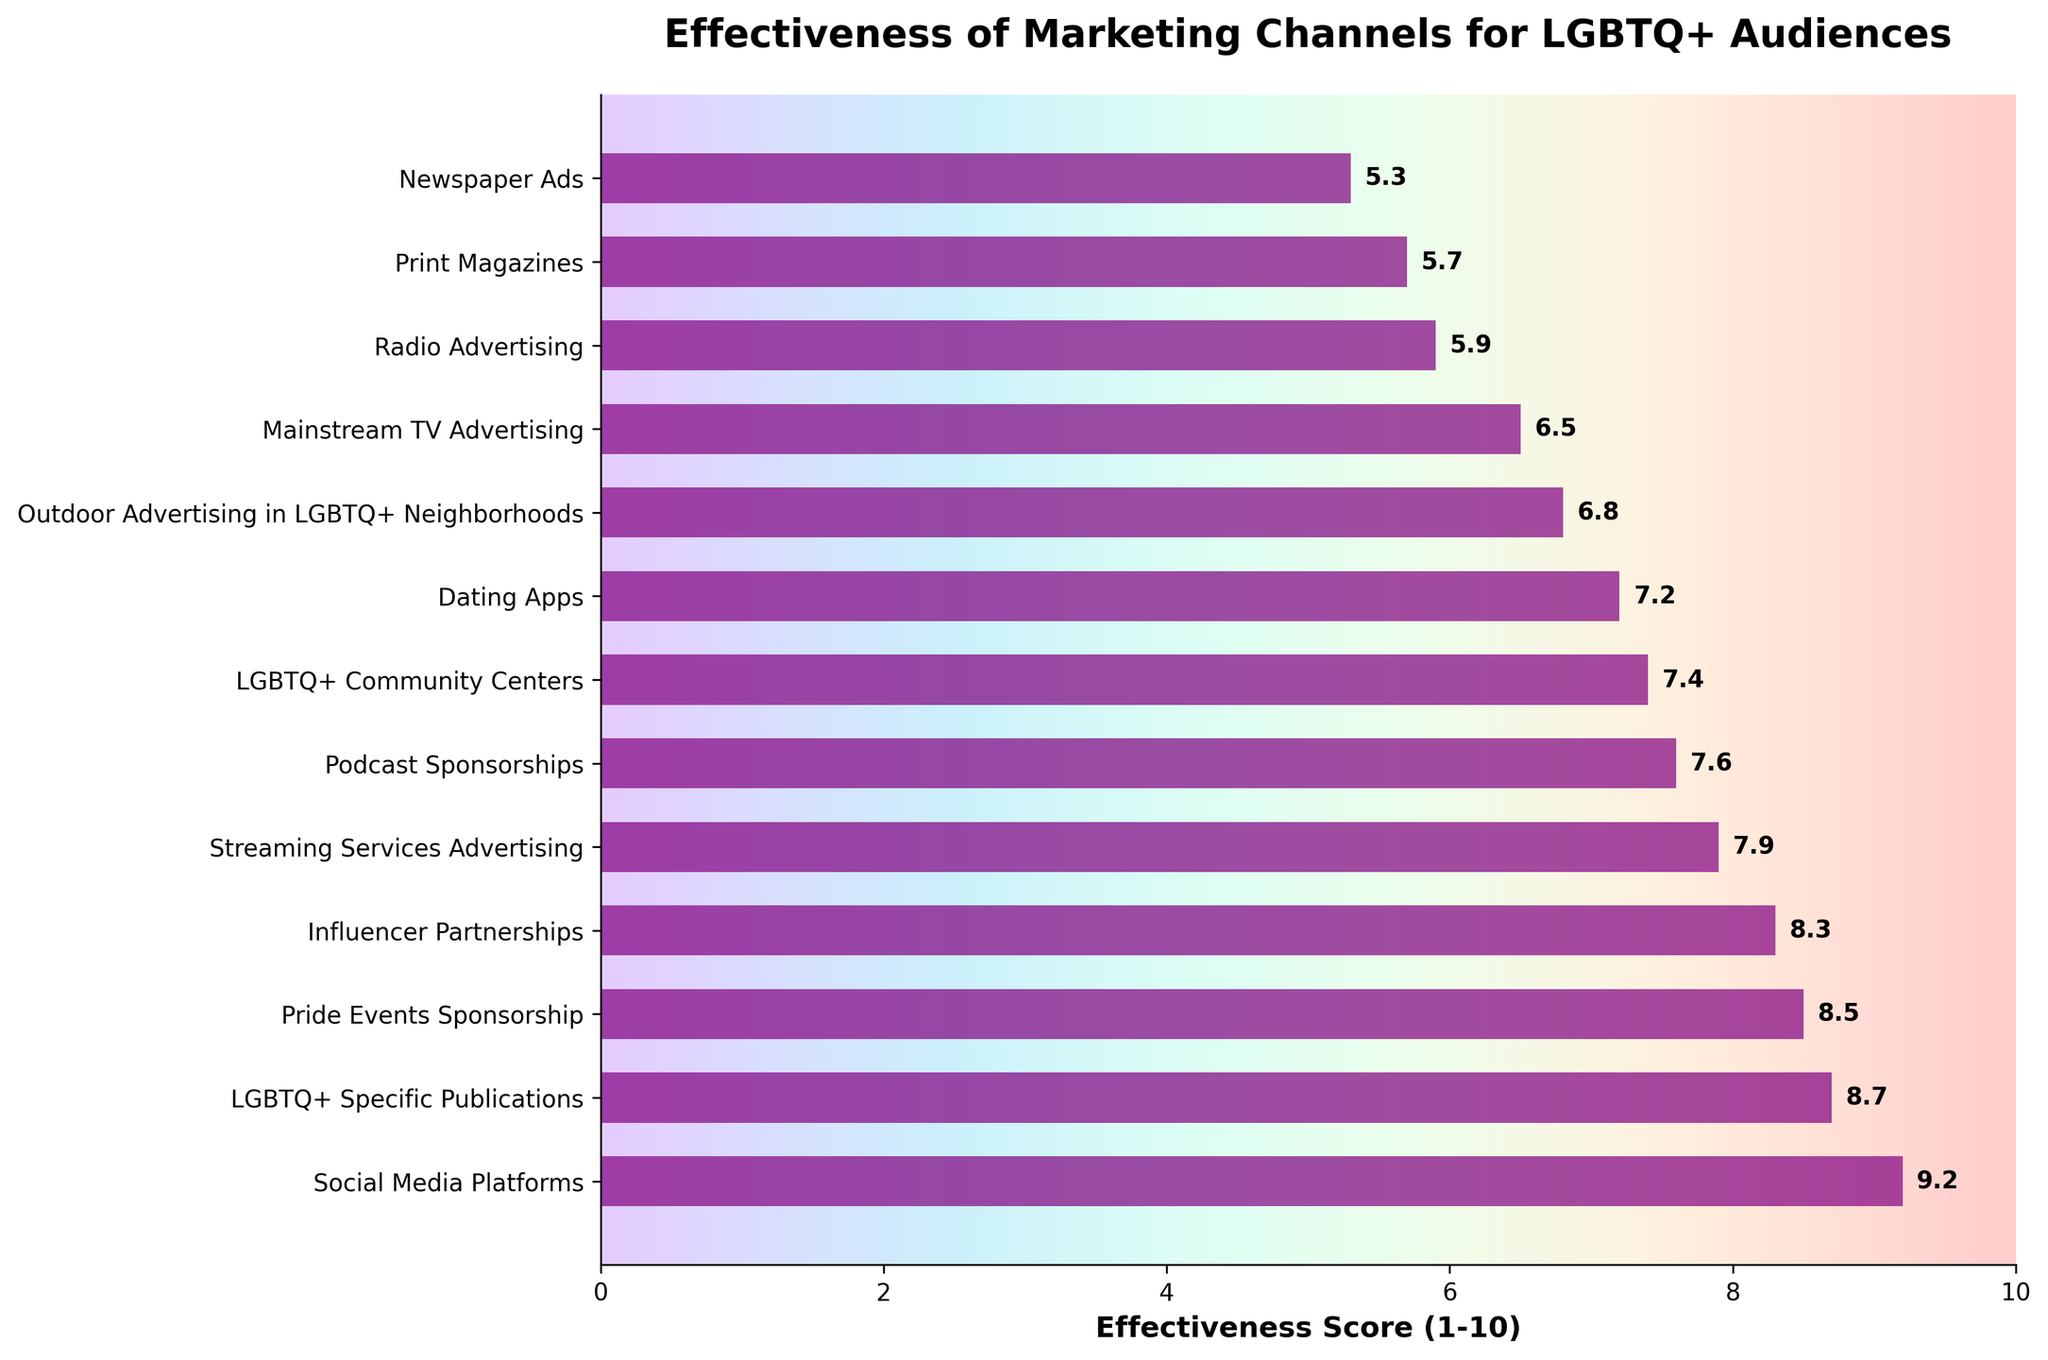Which marketing channel has the highest effectiveness score for reaching LGBTQ+ audiences? The bar representing "Social Media Platforms" has the highest position on the y-axis and the longest bar length with an effectiveness score of 9.2.
Answer: Social Media Platforms Which two marketing channels have the closest effectiveness scores to each other? "Podcast Sponsorships" (7.6) and "LGBTQ+ Community Centers" (7.4) have very close effectiveness scores visually and numerically.
Answer: Podcast Sponsorships and LGBTQ+ Community Centers Which marketing channels have an effectiveness score greater than 8? The bars for "Social Media Platforms", "LGBTQ+ Specific Publications", "Pride Events Sponsorship", and "Influencer Partnerships" extend past the 8 mark on the x-axis.
Answer: Social Media Platforms, LGBTQ+ Specific Publications, Pride Events Sponsorship, Influencer Partnerships What is the total effectiveness score of the bottom three marketing channels? The scores for "Print Magazines" (5.7), "Newspaper Ads" (5.3), and "Radio Advertising" (5.9) add up to 5.7 + 5.3 + 5.9 = 16.9.
Answer: 16.9 How much higher is the effectiveness score of Streaming Services Advertising compared to Newspaper Ads? "Streaming Services Advertising" has a score of 7.9, and "Newspaper Ads" has 5.3. The difference is 7.9 - 5.3 = 2.6.
Answer: 2.6 Are there more marketing channels with effectiveness scores above or below 7? Visual inspection shows 5 channels above 7 (7.2-9.2) and 8 channels below 7 (5.3-6.8).
Answer: Below 7 What is the average effectiveness score of the top five marketing channels? The top five scores are 9.2, 8.7, 8.5, 8.3, and 7.9. Average is (9.2 + 8.7 + 8.5 + 8.3 + 7.9) / 5 = 8.52.
Answer: 8.5 Which marketing channel has the lowest effectiveness score and what is it? The bar for "Newspaper Ads" is the shortest, indicating the lowest effectiveness score of 5.3.
Answer: Newspaper Ads, 5.3 